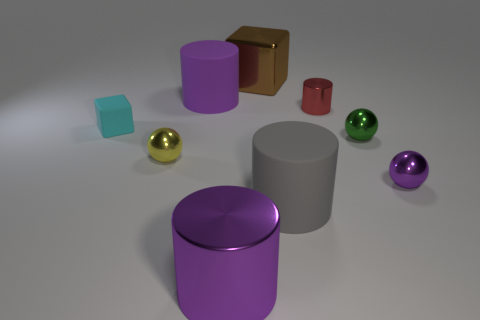Add 1 rubber cylinders. How many objects exist? 10 Subtract all spheres. How many objects are left? 6 Add 5 tiny cubes. How many tiny cubes exist? 6 Subtract 0 blue spheres. How many objects are left? 9 Subtract all small matte things. Subtract all tiny purple metallic balls. How many objects are left? 7 Add 5 yellow spheres. How many yellow spheres are left? 6 